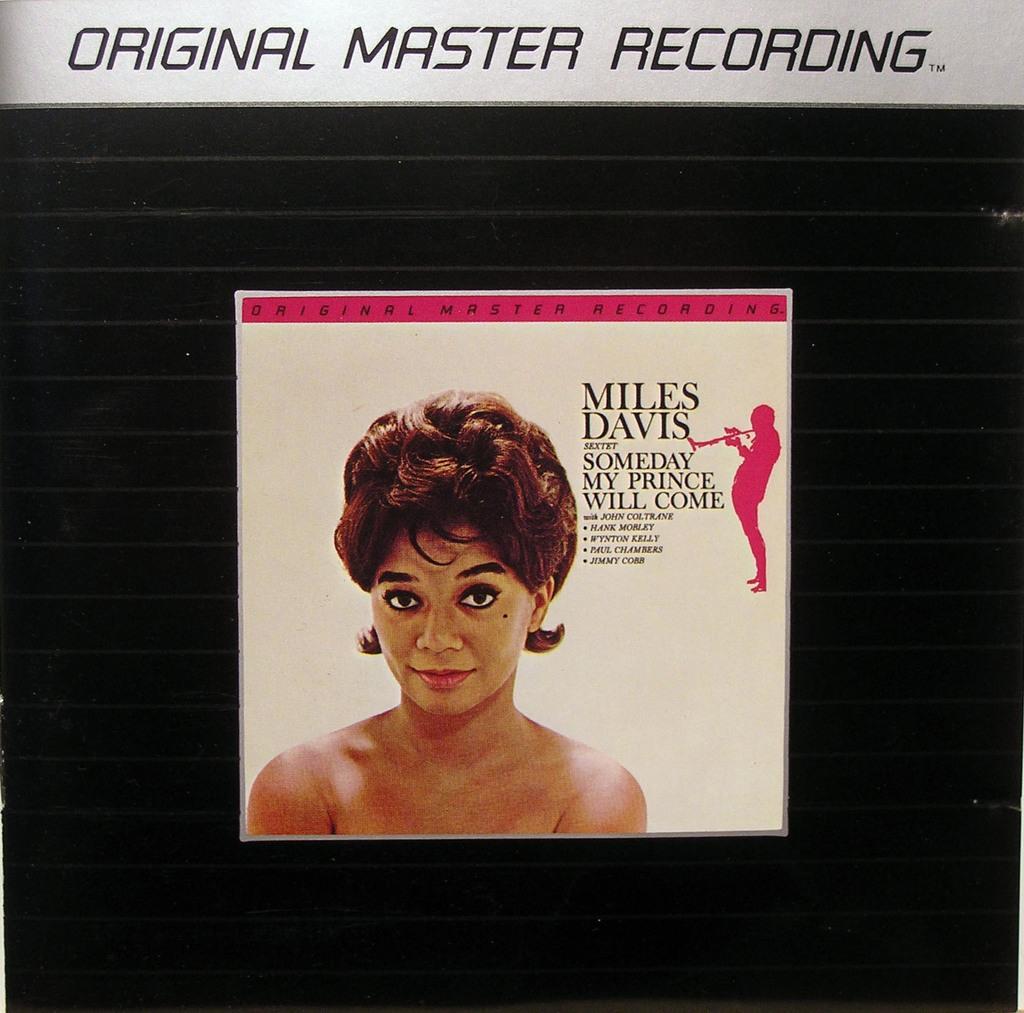Describe this image in one or two sentences. This image looks like an edited photo in which I can see a woman, text and a person holding a musical instrument. 